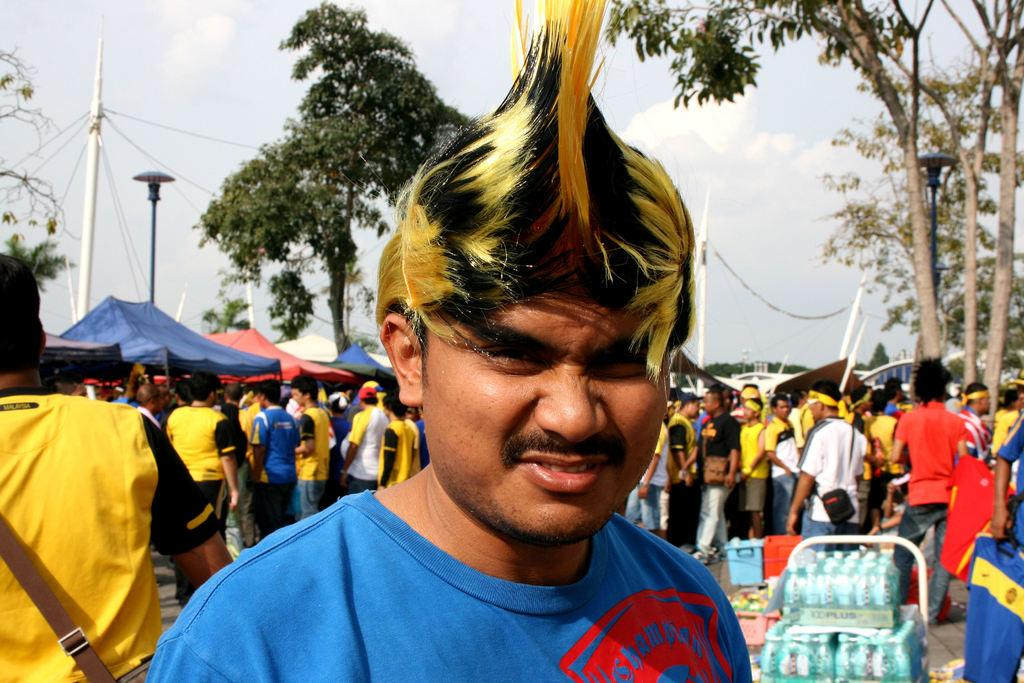How many people are in the image? There are people in the image, but the exact number is not specified. What is one person holding in the image? One person is holding a t-shirt in the image. What type of natural vegetation is present in the image? There are trees in the image. What type of objects can be seen in the image that are typically used for storage or transportation? There are boxes in the image. What type of temporary shelter is present in the image? There are tents in the image. What type of structural elements can be seen in the image? There are poles in the image. What type of flexible material is present in the image that is often used for tying or securing objects? There are ropes in the image. What part of the natural environment is visible in the image? The sky is visible in the image. How many cows are visible in the image? There are no cows present in the image. 